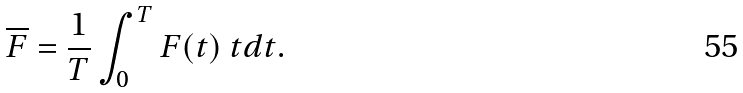<formula> <loc_0><loc_0><loc_500><loc_500>\overline { F } = \frac { 1 } { T } \int _ { 0 } ^ { T } F ( t ) \ t d t .</formula> 